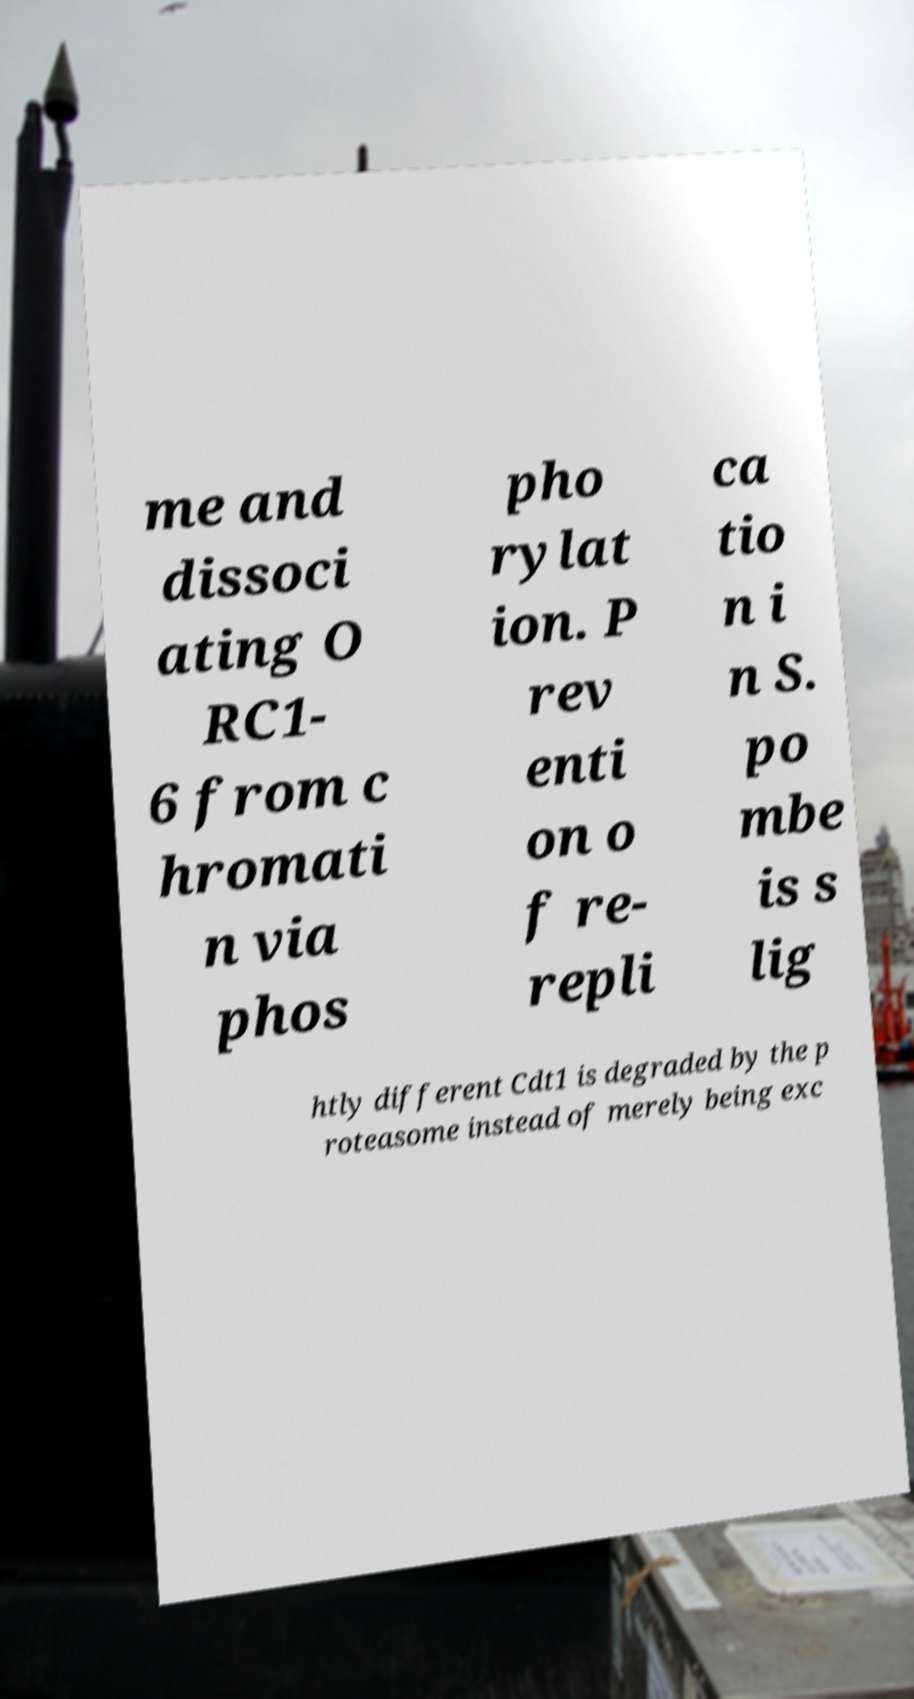Can you read and provide the text displayed in the image?This photo seems to have some interesting text. Can you extract and type it out for me? me and dissoci ating O RC1- 6 from c hromati n via phos pho rylat ion. P rev enti on o f re- repli ca tio n i n S. po mbe is s lig htly different Cdt1 is degraded by the p roteasome instead of merely being exc 